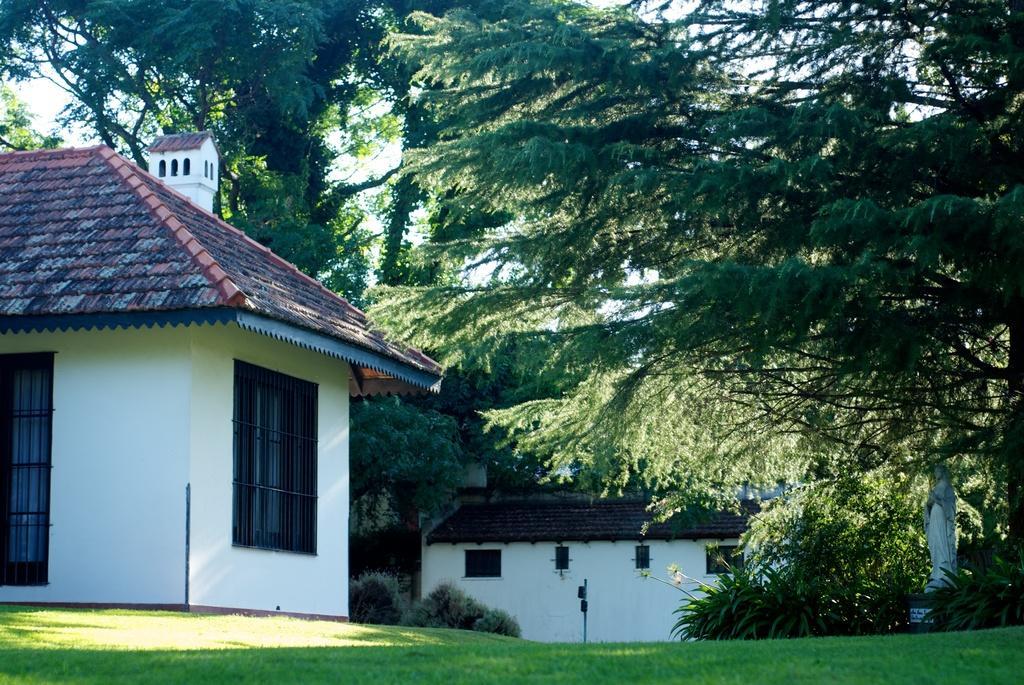Can you describe this image briefly? In this image we can see some grass, there are some houses and in the background of the image there are some trees and clear sky. 